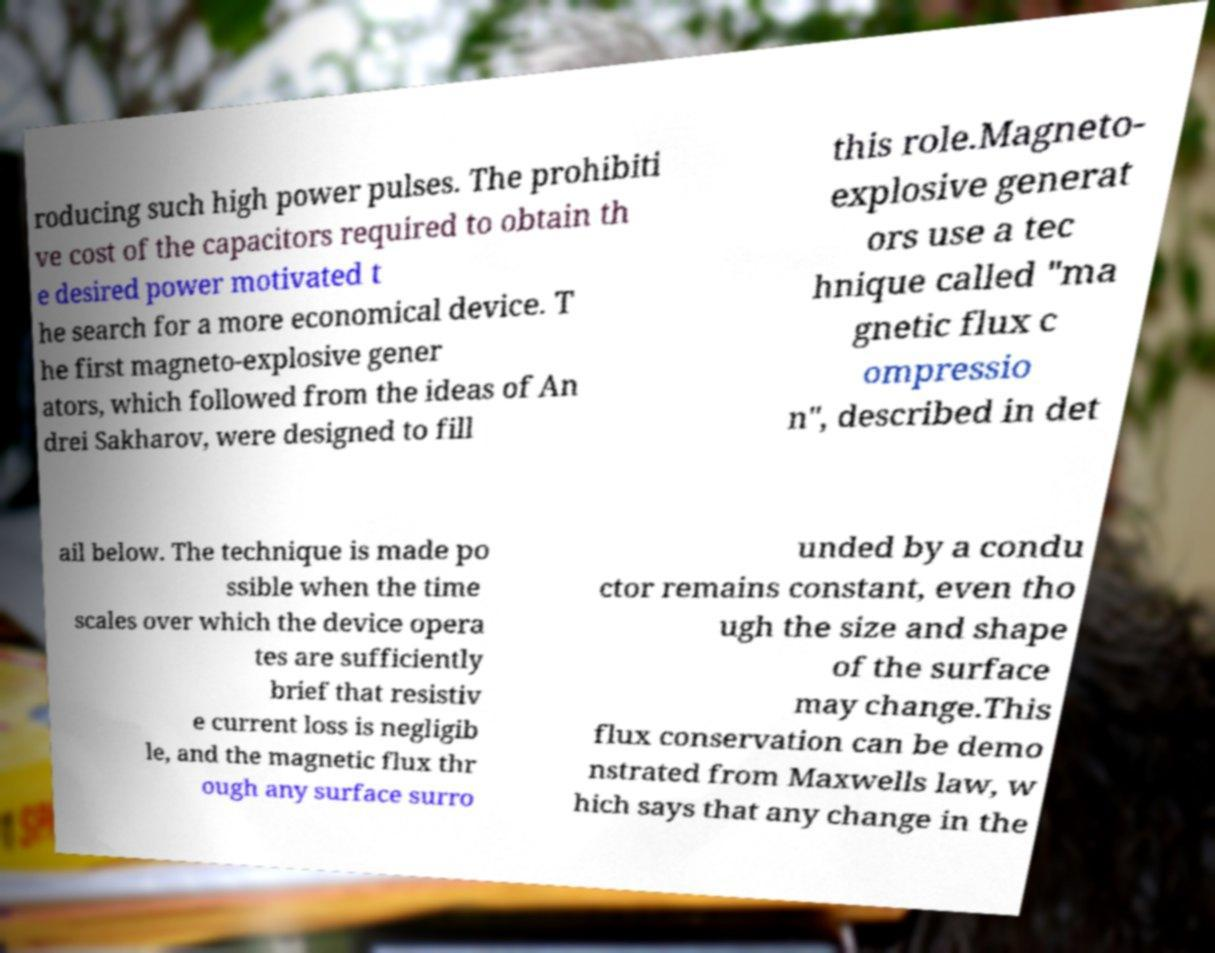Can you read and provide the text displayed in the image?This photo seems to have some interesting text. Can you extract and type it out for me? roducing such high power pulses. The prohibiti ve cost of the capacitors required to obtain th e desired power motivated t he search for a more economical device. T he first magneto-explosive gener ators, which followed from the ideas of An drei Sakharov, were designed to fill this role.Magneto- explosive generat ors use a tec hnique called "ma gnetic flux c ompressio n", described in det ail below. The technique is made po ssible when the time scales over which the device opera tes are sufficiently brief that resistiv e current loss is negligib le, and the magnetic flux thr ough any surface surro unded by a condu ctor remains constant, even tho ugh the size and shape of the surface may change.This flux conservation can be demo nstrated from Maxwells law, w hich says that any change in the 